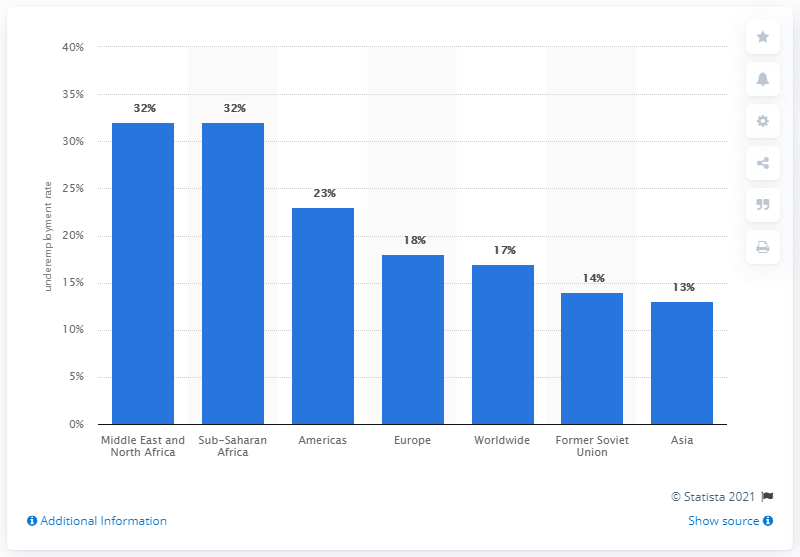Indicate a few pertinent items in this graphic. The underemployment rate in Europe was 18% in 2011, indicating that a significant portion of the workforce was not fully employed in their preferred field or job. In 2011, the worldwide underemployment rate was 17%. 